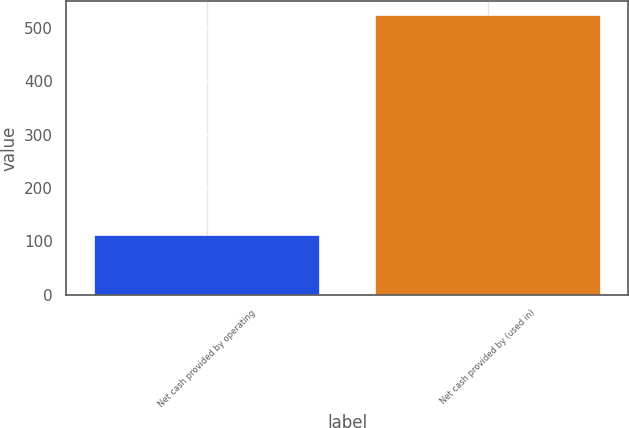<chart> <loc_0><loc_0><loc_500><loc_500><bar_chart><fcel>Net cash provided by operating<fcel>Net cash provided by (used in)<nl><fcel>112.3<fcel>523.3<nl></chart> 